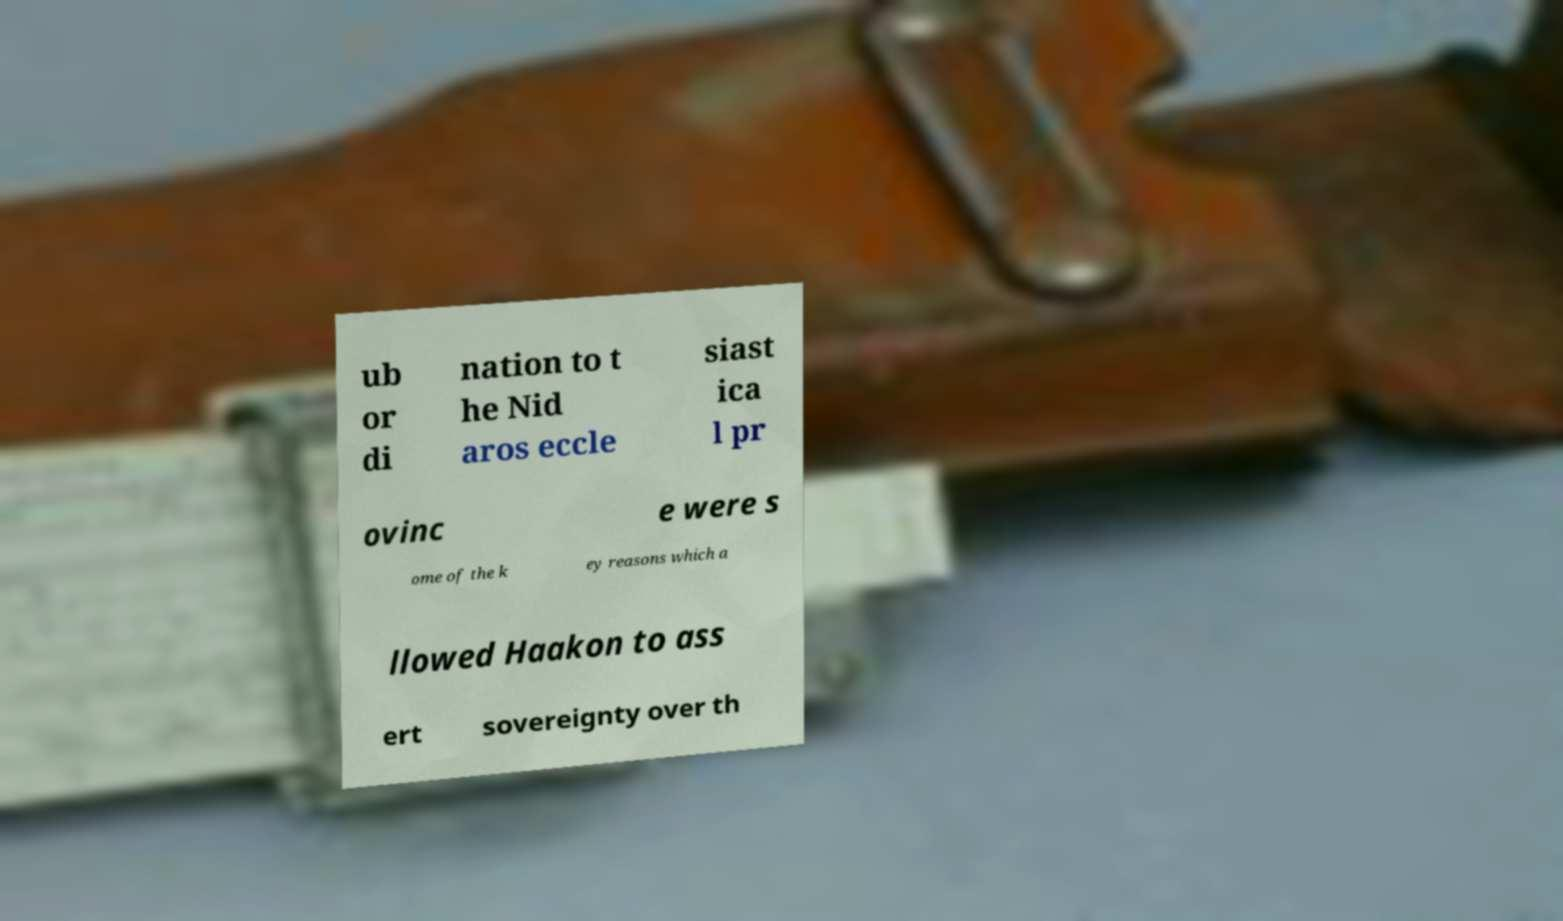For documentation purposes, I need the text within this image transcribed. Could you provide that? ub or di nation to t he Nid aros eccle siast ica l pr ovinc e were s ome of the k ey reasons which a llowed Haakon to ass ert sovereignty over th 